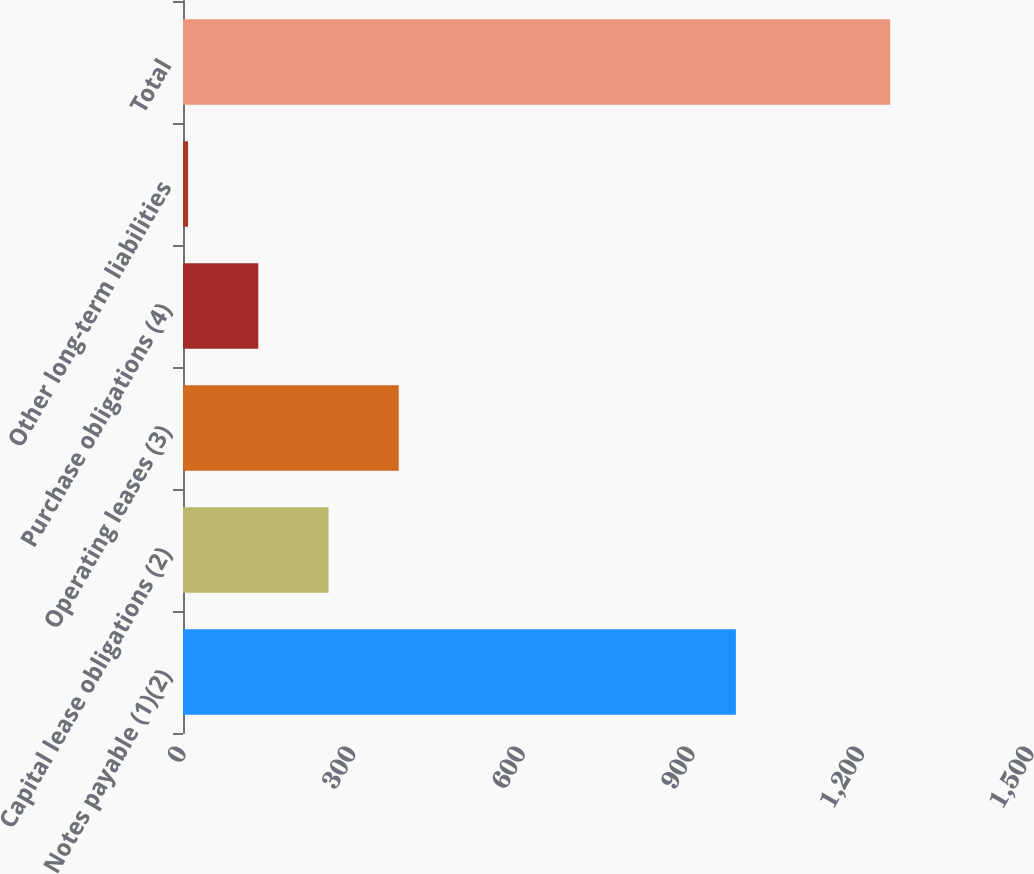<chart> <loc_0><loc_0><loc_500><loc_500><bar_chart><fcel>Notes payable (1)(2)<fcel>Capital lease obligations (2)<fcel>Operating leases (3)<fcel>Purchase obligations (4)<fcel>Other long-term liabilities<fcel>Total<nl><fcel>978<fcel>257.4<fcel>381.6<fcel>133.2<fcel>9<fcel>1251<nl></chart> 